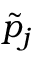<formula> <loc_0><loc_0><loc_500><loc_500>\tilde { p } _ { j }</formula> 